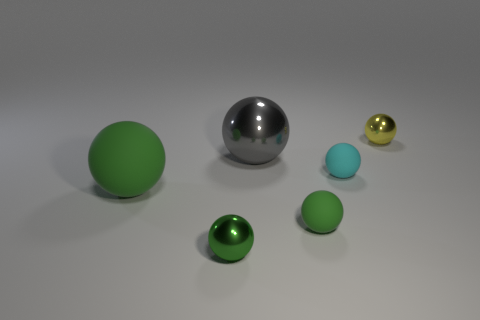There is a tiny green sphere in front of the small green matte thing; what is its material?
Provide a short and direct response. Metal. How many matte things are either green things or tiny green objects?
Provide a short and direct response. 2. Is there a cyan ball that has the same size as the cyan thing?
Your answer should be compact. No. Is the number of shiny things in front of the tiny yellow object greater than the number of small cyan matte blocks?
Offer a terse response. Yes. What number of large objects are either gray balls or blue shiny cylinders?
Make the answer very short. 1. What number of other objects are the same shape as the gray thing?
Offer a terse response. 5. There is a large thing that is right of the large object that is in front of the cyan sphere; what is its material?
Your answer should be very brief. Metal. There is a green matte sphere on the left side of the big metal ball; what is its size?
Your response must be concise. Large. How many blue things are big metallic objects or things?
Your response must be concise. 0. What material is the gray object that is the same shape as the tiny green rubber object?
Make the answer very short. Metal. 